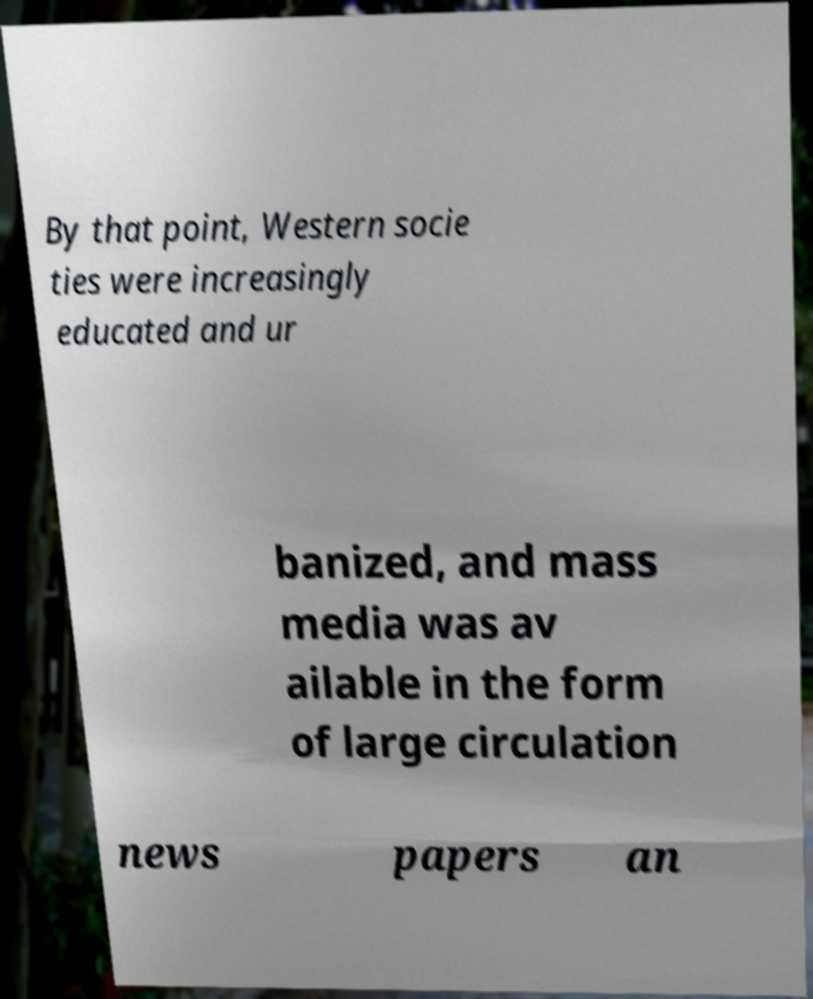Can you read and provide the text displayed in the image?This photo seems to have some interesting text. Can you extract and type it out for me? By that point, Western socie ties were increasingly educated and ur banized, and mass media was av ailable in the form of large circulation news papers an 